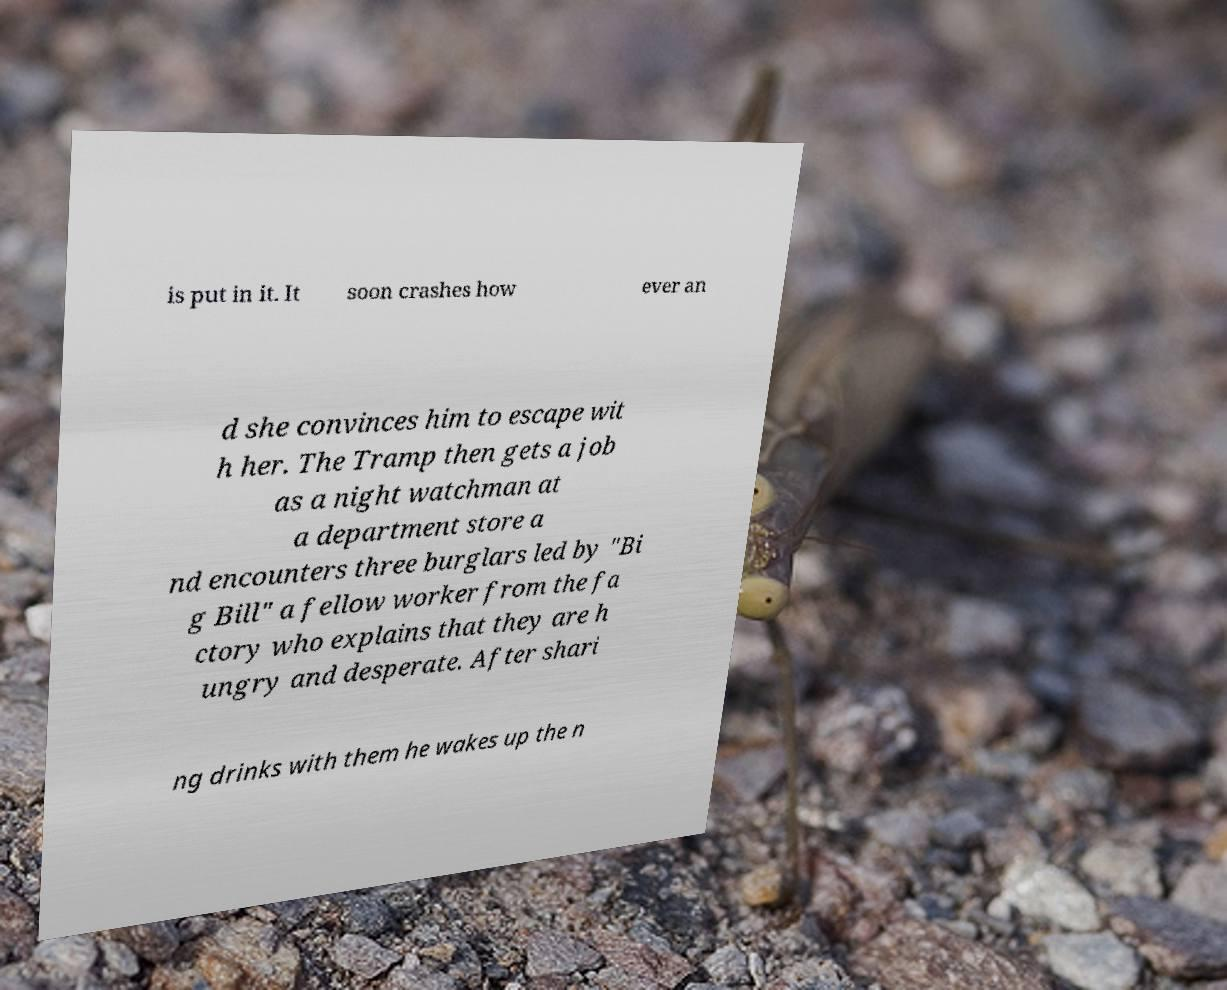I need the written content from this picture converted into text. Can you do that? is put in it. It soon crashes how ever an d she convinces him to escape wit h her. The Tramp then gets a job as a night watchman at a department store a nd encounters three burglars led by "Bi g Bill" a fellow worker from the fa ctory who explains that they are h ungry and desperate. After shari ng drinks with them he wakes up the n 